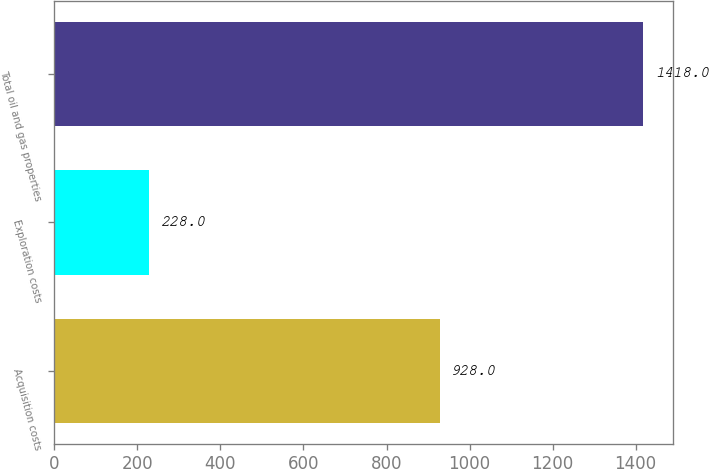<chart> <loc_0><loc_0><loc_500><loc_500><bar_chart><fcel>Acquisition costs<fcel>Exploration costs<fcel>Total oil and gas properties<nl><fcel>928<fcel>228<fcel>1418<nl></chart> 